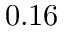<formula> <loc_0><loc_0><loc_500><loc_500>0 . 1 6</formula> 